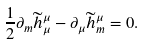Convert formula to latex. <formula><loc_0><loc_0><loc_500><loc_500>\frac { 1 } { 2 } \partial _ { m } \widetilde { h } _ { \mu } ^ { \mu } - \partial _ { \mu } \widetilde { h } _ { m } ^ { \mu } = 0 .</formula> 